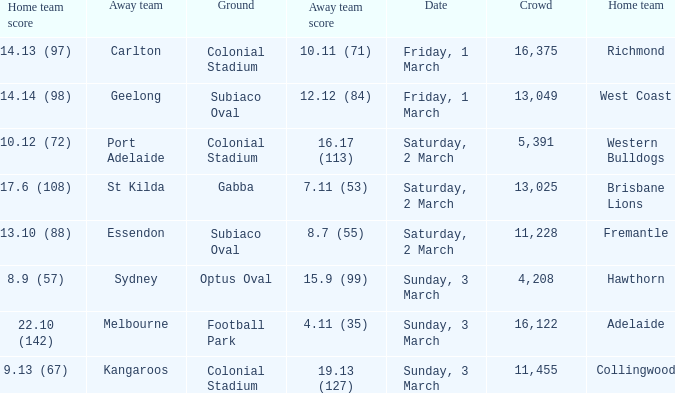Could you parse the entire table? {'header': ['Home team score', 'Away team', 'Ground', 'Away team score', 'Date', 'Crowd', 'Home team'], 'rows': [['14.13 (97)', 'Carlton', 'Colonial Stadium', '10.11 (71)', 'Friday, 1 March', '16,375', 'Richmond'], ['14.14 (98)', 'Geelong', 'Subiaco Oval', '12.12 (84)', 'Friday, 1 March', '13,049', 'West Coast'], ['10.12 (72)', 'Port Adelaide', 'Colonial Stadium', '16.17 (113)', 'Saturday, 2 March', '5,391', 'Western Bulldogs'], ['17.6 (108)', 'St Kilda', 'Gabba', '7.11 (53)', 'Saturday, 2 March', '13,025', 'Brisbane Lions'], ['13.10 (88)', 'Essendon', 'Subiaco Oval', '8.7 (55)', 'Saturday, 2 March', '11,228', 'Fremantle'], ['8.9 (57)', 'Sydney', 'Optus Oval', '15.9 (99)', 'Sunday, 3 March', '4,208', 'Hawthorn'], ['22.10 (142)', 'Melbourne', 'Football Park', '4.11 (35)', 'Sunday, 3 March', '16,122', 'Adelaide'], ['9.13 (67)', 'Kangaroos', 'Colonial Stadium', '19.13 (127)', 'Sunday, 3 March', '11,455', 'Collingwood']]} What was the ground for away team essendon? Subiaco Oval. 